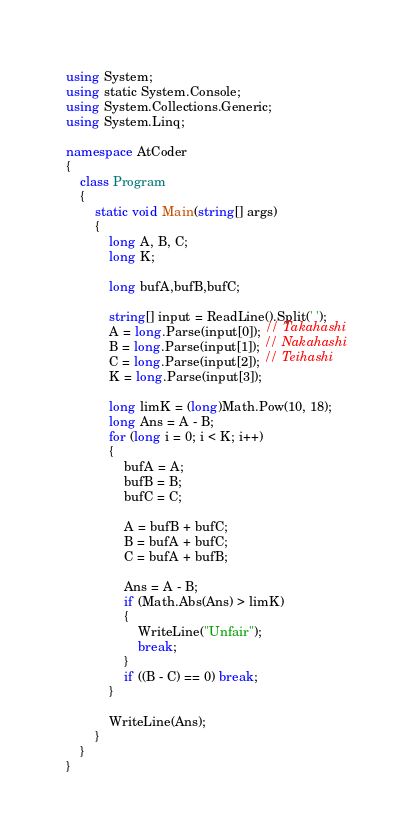<code> <loc_0><loc_0><loc_500><loc_500><_C#_>using System;
using static System.Console;
using System.Collections.Generic;
using System.Linq;

namespace AtCoder
{
    class Program
    {
        static void Main(string[] args)
        {
            long A, B, C;
            long K;

            long bufA,bufB,bufC;

            string[] input = ReadLine().Split(' ');
            A = long.Parse(input[0]); // Takahashi
            B = long.Parse(input[1]); // Nakahashi
            C = long.Parse(input[2]); // Teihashi
            K = long.Parse(input[3]);

            long limK = (long)Math.Pow(10, 18);
            long Ans = A - B;
            for (long i = 0; i < K; i++)
            {
                bufA = A;
                bufB = B;
                bufC = C;

                A = bufB + bufC;
                B = bufA + bufC;
                C = bufA + bufB;

                Ans = A - B;
                if (Math.Abs(Ans) > limK)
                {
                    WriteLine("Unfair");
                    break;
                }
                if ((B - C) == 0) break;
            }

            WriteLine(Ans);
        }
    }
}
</code> 